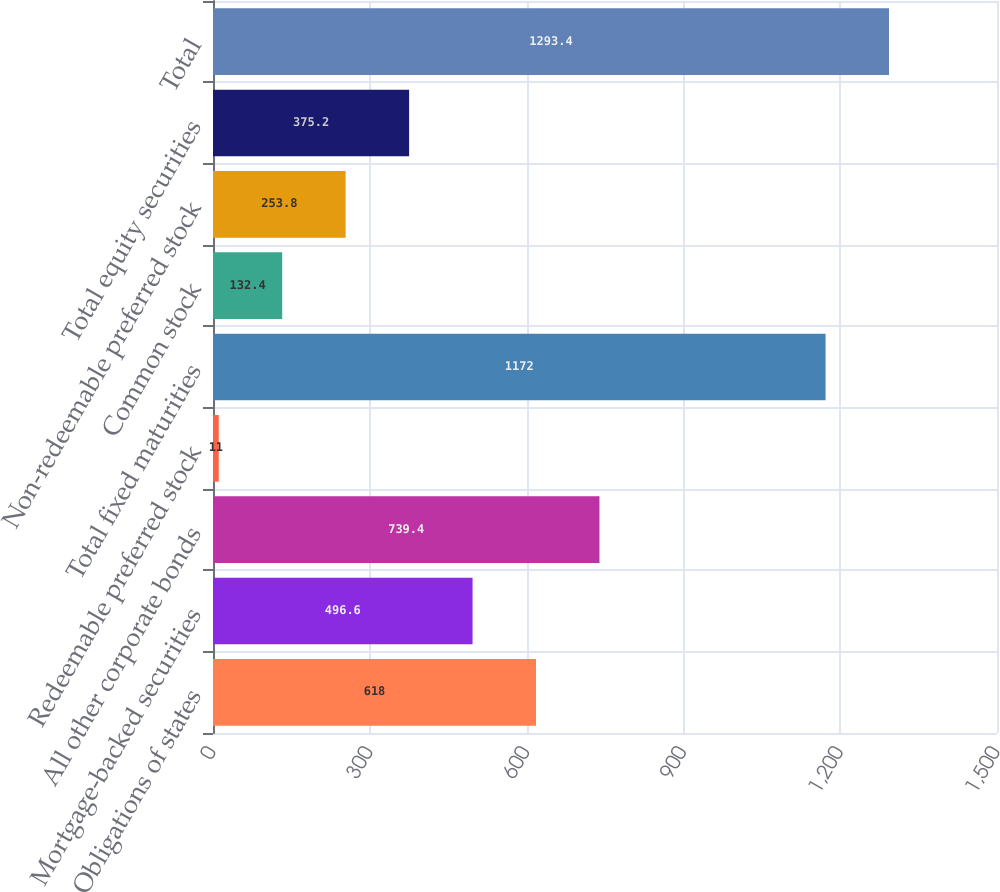Convert chart to OTSL. <chart><loc_0><loc_0><loc_500><loc_500><bar_chart><fcel>Obligations of states<fcel>Mortgage-backed securities<fcel>All other corporate bonds<fcel>Redeemable preferred stock<fcel>Total fixed maturities<fcel>Common stock<fcel>Non-redeemable preferred stock<fcel>Total equity securities<fcel>Total<nl><fcel>618<fcel>496.6<fcel>739.4<fcel>11<fcel>1172<fcel>132.4<fcel>253.8<fcel>375.2<fcel>1293.4<nl></chart> 